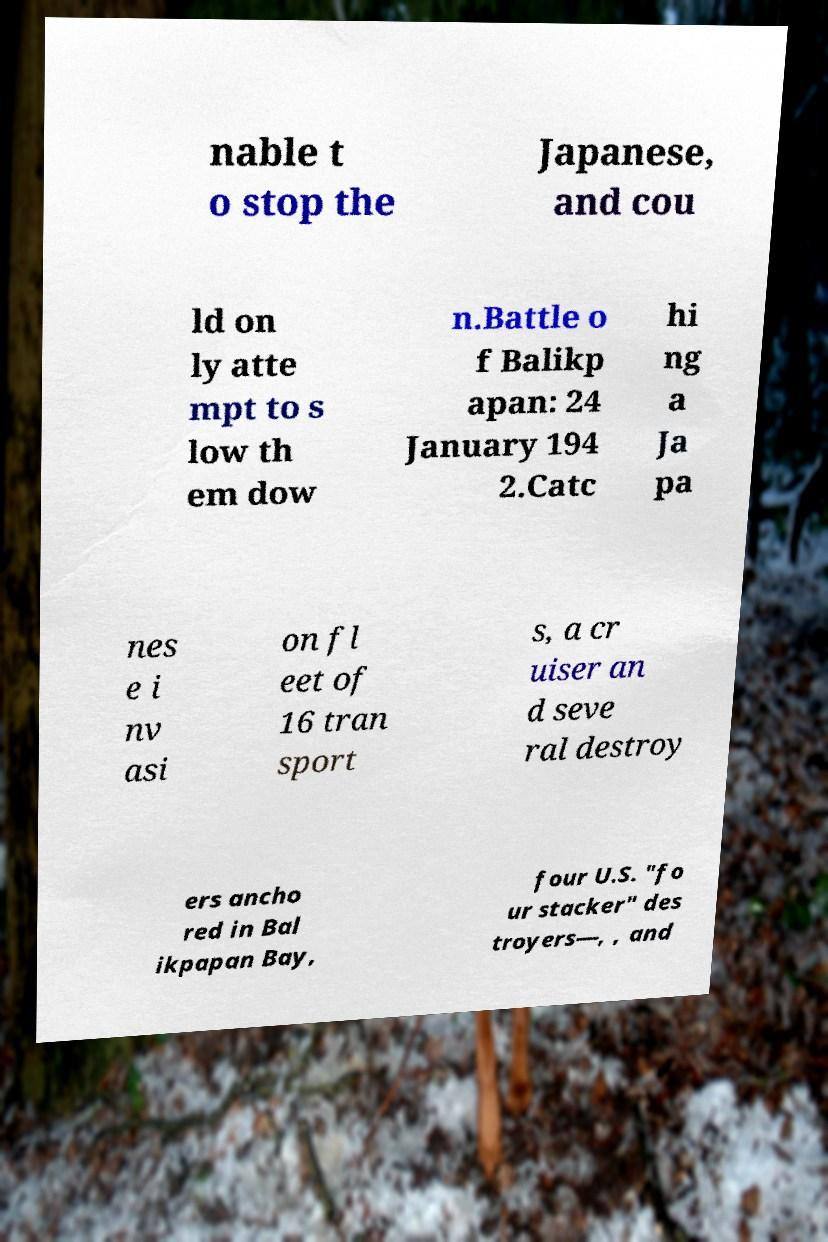Please identify and transcribe the text found in this image. nable t o stop the Japanese, and cou ld on ly atte mpt to s low th em dow n.Battle o f Balikp apan: 24 January 194 2.Catc hi ng a Ja pa nes e i nv asi on fl eet of 16 tran sport s, a cr uiser an d seve ral destroy ers ancho red in Bal ikpapan Bay, four U.S. "fo ur stacker" des troyers—, , and 